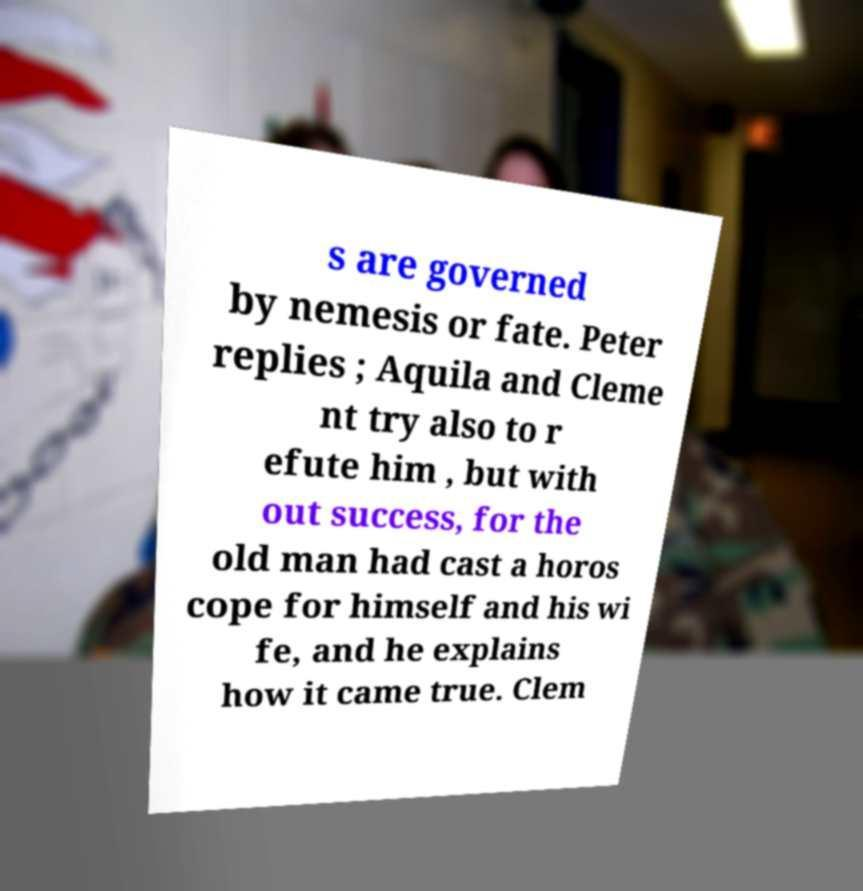Can you read and provide the text displayed in the image?This photo seems to have some interesting text. Can you extract and type it out for me? s are governed by nemesis or fate. Peter replies ; Aquila and Cleme nt try also to r efute him , but with out success, for the old man had cast a horos cope for himself and his wi fe, and he explains how it came true. Clem 